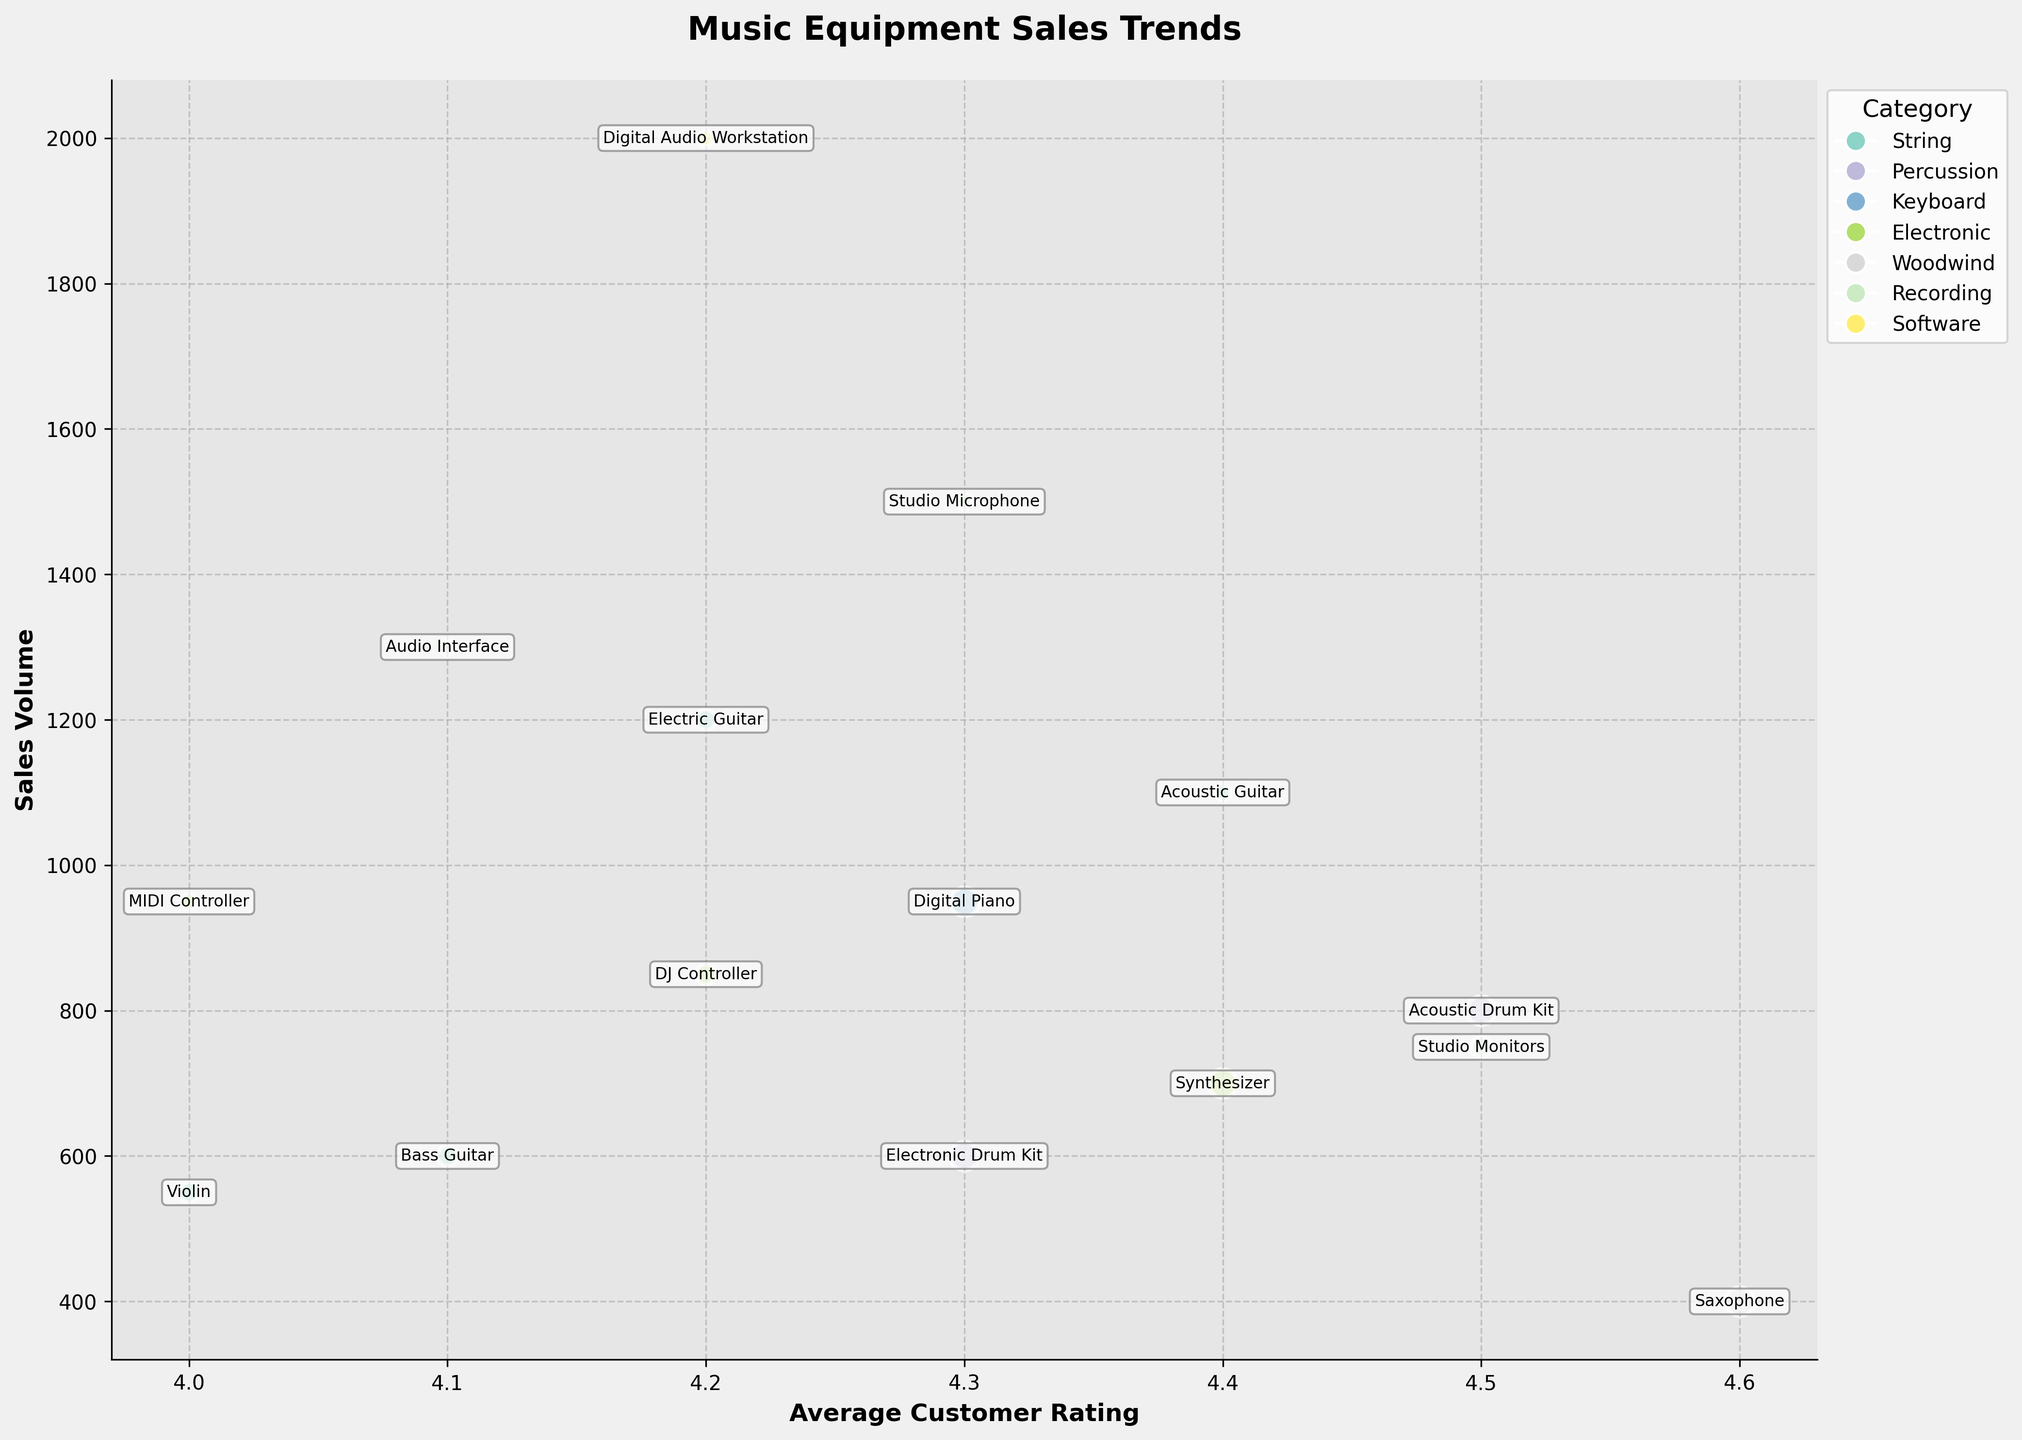What is the title of the plot? The title of the plot is displayed at the top of the figure, indicating the overall subject being analyzed.
Answer: Music Equipment Sales Trends What are the labels of the X and Y axes? The X and Y axes have labels which describe what each axis represents. The X axis label is 'Average Customer Rating', and the Y axis label is 'Sales Volume'.
Answer: Average Customer Rating; Sales Volume How many instrument categories are displayed in the plot? The legend on the right side of the plot lists all the categories, each represented by a different color. There are 7 categories displayed.
Answer: 7 Which instrument has the highest sales volume? By looking at the Y axis and finding the highest point, we see that the 'Digital Audio Workstation' has the highest sales volume.
Answer: Digital Audio Workstation What is the average customer rating of the electronic drum kit? The electronic drum kit's average customer rating can be found on the X axis at the point where the electronic drum kit is labeled. It is 4.3.
Answer: 4.3 Compare the sales volumes of studio microphones and digital audio workstations. Which has a higher sales volume and by how much? By examining the Y axis positions of the studio microphone and the digital audio workstation, we see the digital audio workstation has a higher sales volume. Digital Audio Workstation (2000) - Studio Microphone (1500) = 500.
Answer: Digital Audio Workstation by 500 Which category has the highest average customer rating across all instruments? By looking at the X axis and identifying the category with the instruments closest to the right, we see that 'Woodwind' with the saxophone has the highest rating of 4.6.
Answer: Woodwind What is the total sales volume of all string instruments? The string instruments are Electric Guitar, Bass Guitar, Violin, and Acoustic Guitar. Summing their sales volumes: 1200 + 600 + 550 + 1100 = 3450.
Answer: 3450 Which instrument in the recording category has a higher average customer rating? Compare the X axis positions for Studio Microphone and Audio Interface under the recording category. Studio Microphone (4.3) > Audio Interface (4.1).
Answer: Studio Microphone 